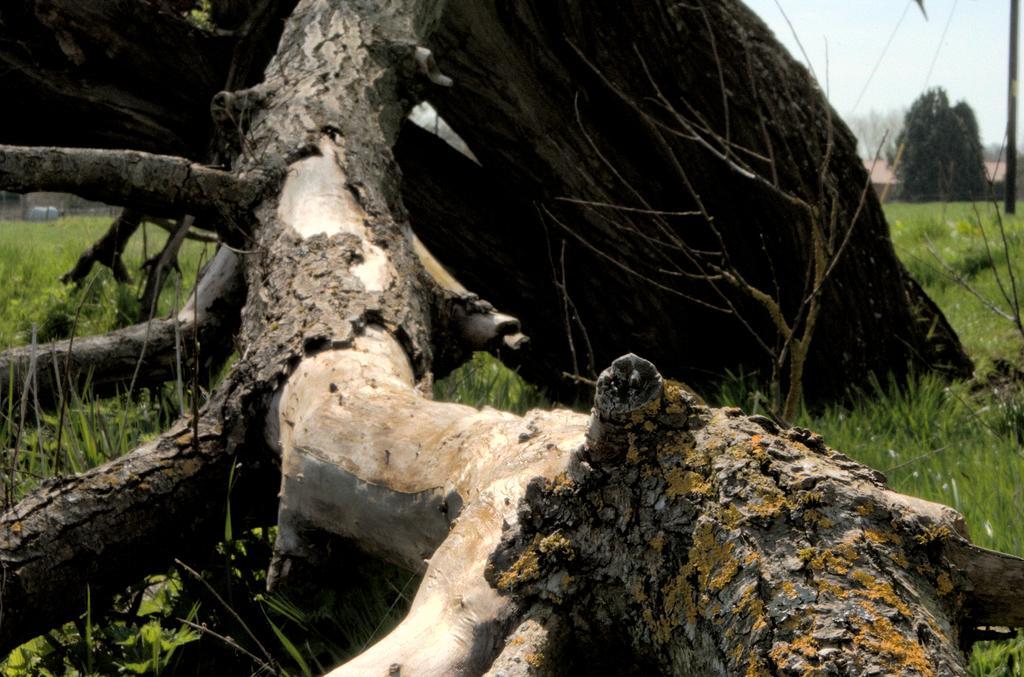Please provide a concise description of this image. In this image we can see logs, grass, pole, trees, and a house. In the background there is sky. 